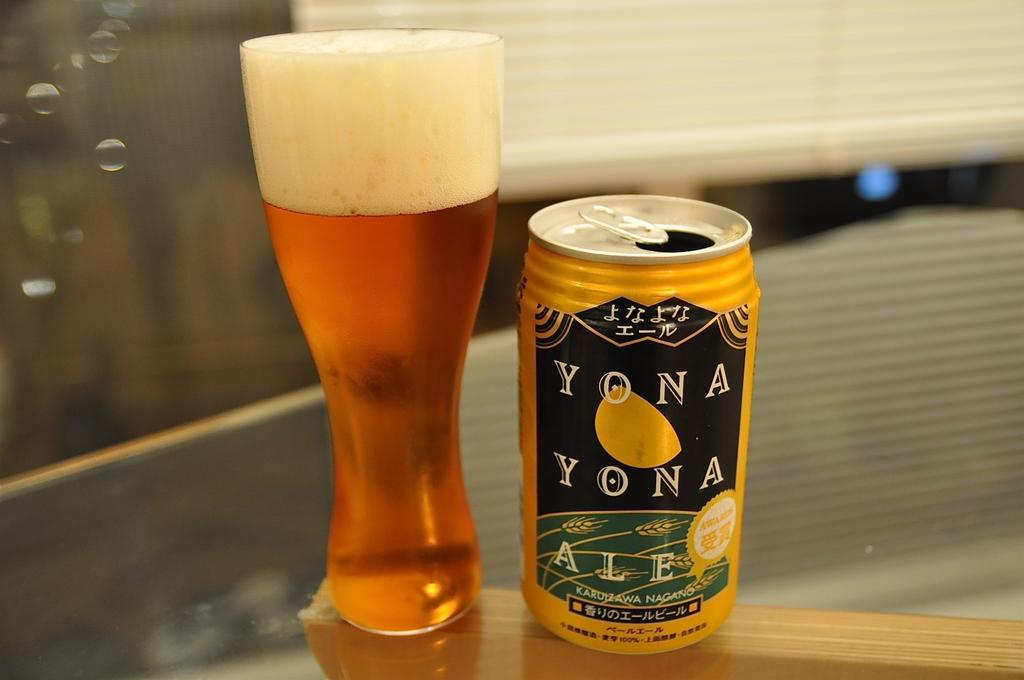<image>
Offer a succinct explanation of the picture presented. A can of Yona Yona ale is next to a filled glass on a table. 